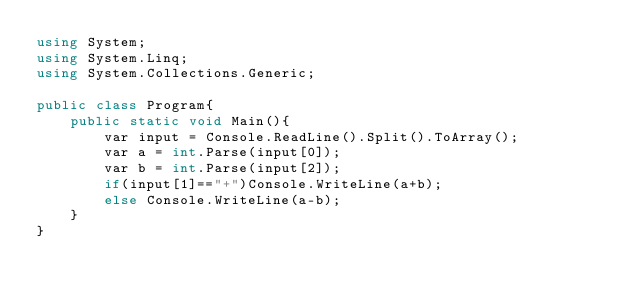<code> <loc_0><loc_0><loc_500><loc_500><_C#_>using System;
using System.Linq;
using System.Collections.Generic;

public class Program{
    public static void Main(){
        var input = Console.ReadLine().Split().ToArray();
        var a = int.Parse(input[0]);
        var b = int.Parse(input[2]);
        if(input[1]=="+")Console.WriteLine(a+b);
        else Console.WriteLine(a-b);
    }
}
</code> 